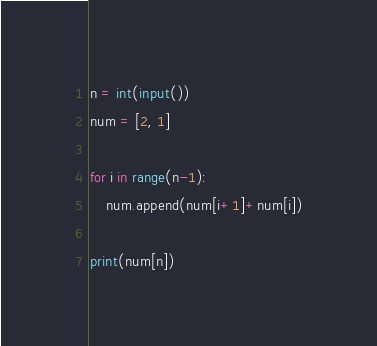<code> <loc_0><loc_0><loc_500><loc_500><_Python_>n = int(input())
num = [2, 1]

for i in range(n-1):
    num.append(num[i+1]+num[i])

print(num[n])</code> 